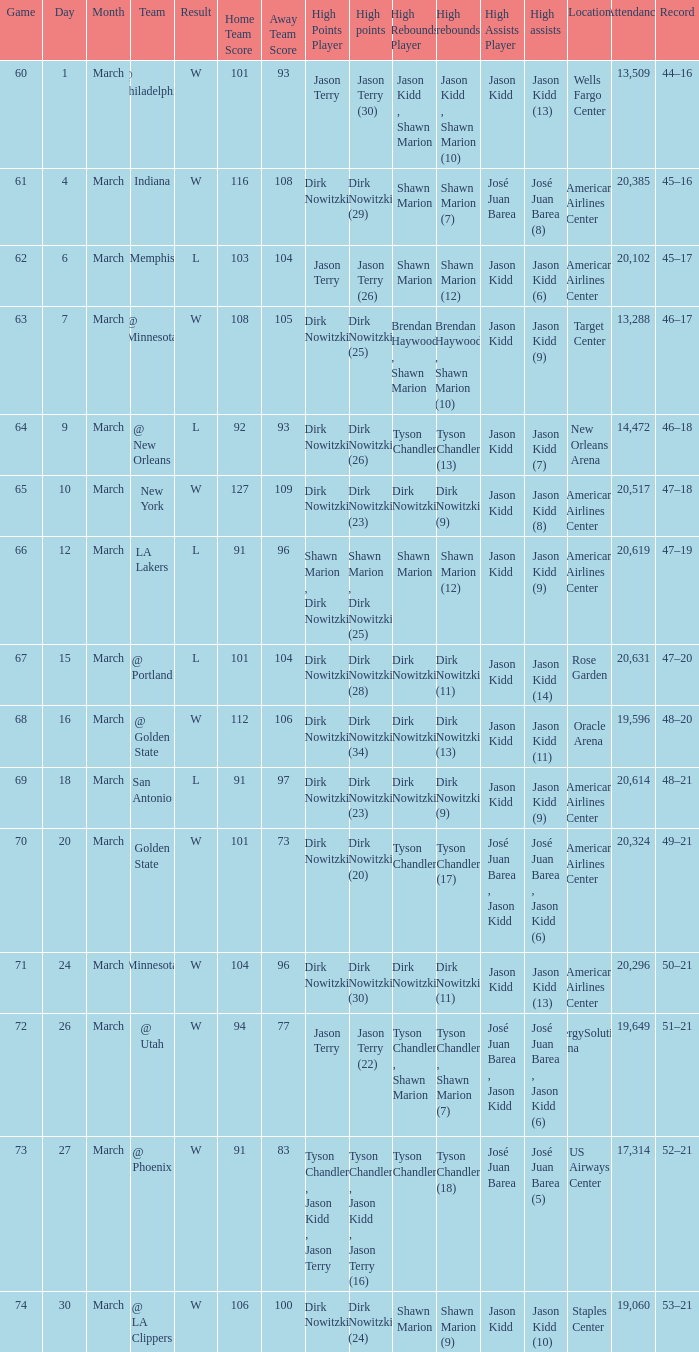Name the high assists for  l 103–104 (ot) Jason Kidd (6). 